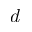<formula> <loc_0><loc_0><loc_500><loc_500>d</formula> 